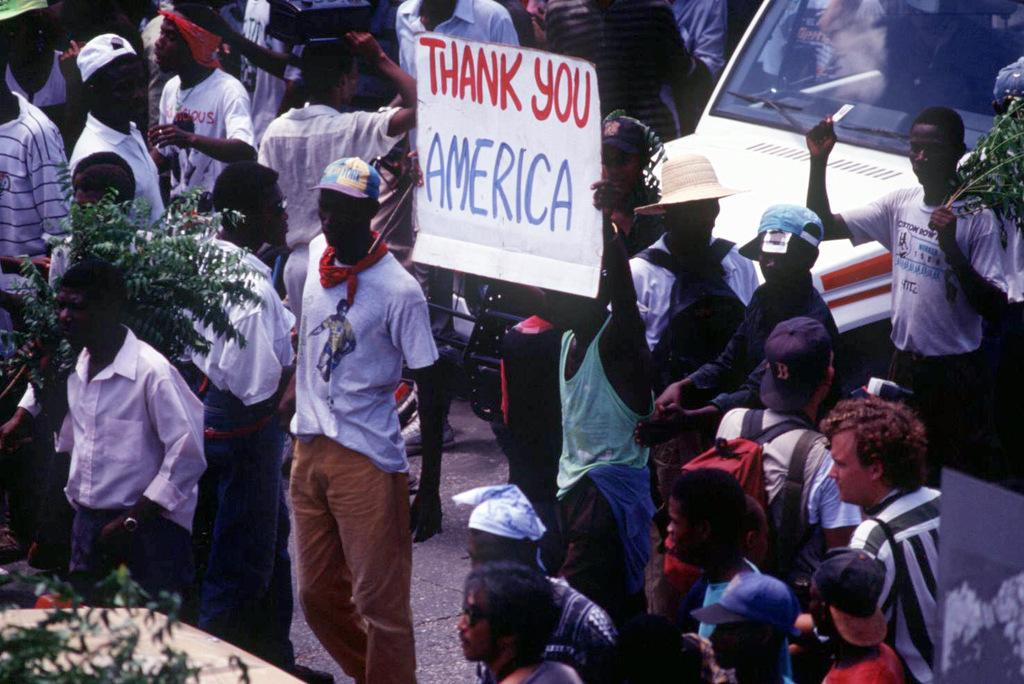What is happening in the image involving the group of people? The people are holding a board with their hands. Can you describe the vehicle in the image? Unfortunately, the provided facts do not mention any details about the vehicle. How many people are in the group? The number of people in the group is not specified in the provided facts. What type of berry is being used to support the beam in the image? There is no mention of a beam or berry in the provided facts, so this question cannot be answered definitively. 